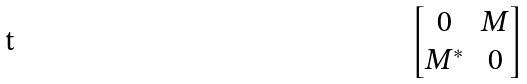<formula> <loc_0><loc_0><loc_500><loc_500>\begin{bmatrix} 0 & M \\ M ^ { * } & 0 \end{bmatrix}</formula> 